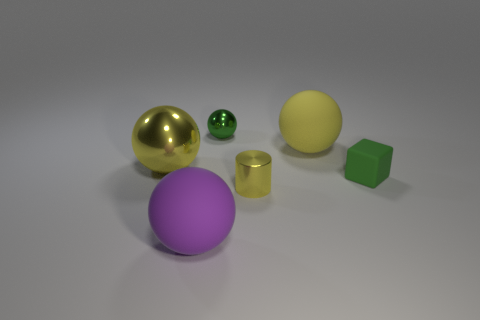Subtract all big purple matte balls. How many balls are left? 3 Subtract all green spheres. How many spheres are left? 3 Subtract all blue spheres. Subtract all gray cylinders. How many spheres are left? 4 Add 4 purple objects. How many objects exist? 10 Subtract all cylinders. How many objects are left? 5 Subtract 1 green cubes. How many objects are left? 5 Subtract all small red rubber blocks. Subtract all balls. How many objects are left? 2 Add 6 large yellow matte balls. How many large yellow matte balls are left? 7 Add 2 large brown matte things. How many large brown matte things exist? 2 